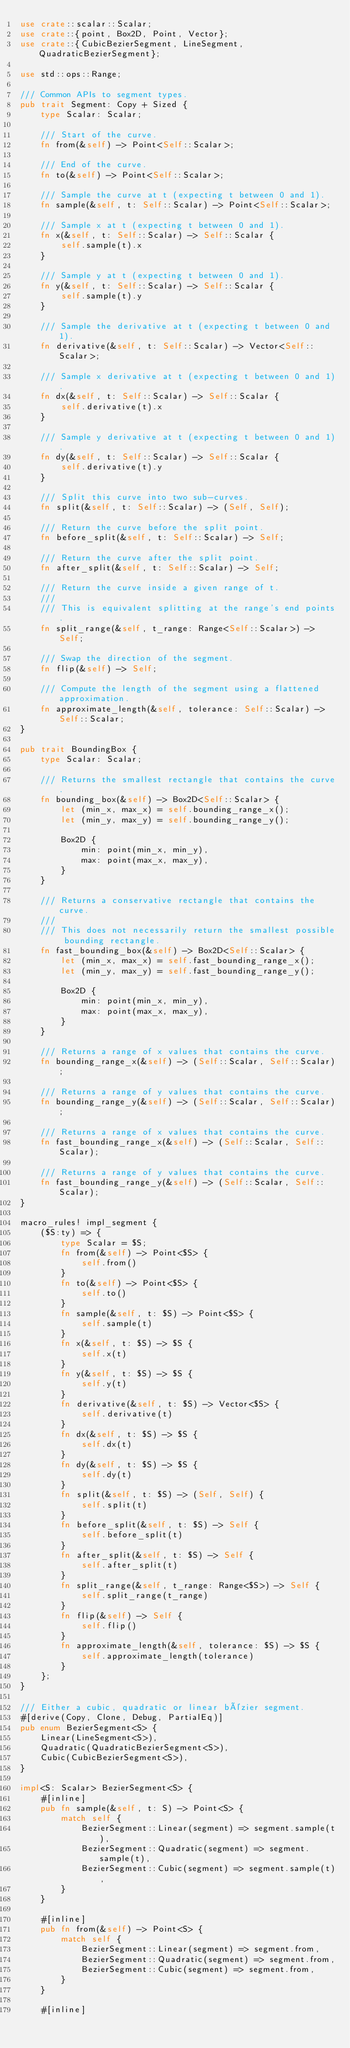Convert code to text. <code><loc_0><loc_0><loc_500><loc_500><_Rust_>use crate::scalar::Scalar;
use crate::{point, Box2D, Point, Vector};
use crate::{CubicBezierSegment, LineSegment, QuadraticBezierSegment};

use std::ops::Range;

/// Common APIs to segment types.
pub trait Segment: Copy + Sized {
    type Scalar: Scalar;

    /// Start of the curve.
    fn from(&self) -> Point<Self::Scalar>;

    /// End of the curve.
    fn to(&self) -> Point<Self::Scalar>;

    /// Sample the curve at t (expecting t between 0 and 1).
    fn sample(&self, t: Self::Scalar) -> Point<Self::Scalar>;

    /// Sample x at t (expecting t between 0 and 1).
    fn x(&self, t: Self::Scalar) -> Self::Scalar {
        self.sample(t).x
    }

    /// Sample y at t (expecting t between 0 and 1).
    fn y(&self, t: Self::Scalar) -> Self::Scalar {
        self.sample(t).y
    }

    /// Sample the derivative at t (expecting t between 0 and 1).
    fn derivative(&self, t: Self::Scalar) -> Vector<Self::Scalar>;

    /// Sample x derivative at t (expecting t between 0 and 1).
    fn dx(&self, t: Self::Scalar) -> Self::Scalar {
        self.derivative(t).x
    }

    /// Sample y derivative at t (expecting t between 0 and 1).
    fn dy(&self, t: Self::Scalar) -> Self::Scalar {
        self.derivative(t).y
    }

    /// Split this curve into two sub-curves.
    fn split(&self, t: Self::Scalar) -> (Self, Self);

    /// Return the curve before the split point.
    fn before_split(&self, t: Self::Scalar) -> Self;

    /// Return the curve after the split point.
    fn after_split(&self, t: Self::Scalar) -> Self;

    /// Return the curve inside a given range of t.
    ///
    /// This is equivalent splitting at the range's end points.
    fn split_range(&self, t_range: Range<Self::Scalar>) -> Self;

    /// Swap the direction of the segment.
    fn flip(&self) -> Self;

    /// Compute the length of the segment using a flattened approximation.
    fn approximate_length(&self, tolerance: Self::Scalar) -> Self::Scalar;
}

pub trait BoundingBox {
    type Scalar: Scalar;

    /// Returns the smallest rectangle that contains the curve.
    fn bounding_box(&self) -> Box2D<Self::Scalar> {
        let (min_x, max_x) = self.bounding_range_x();
        let (min_y, max_y) = self.bounding_range_y();

        Box2D {
            min: point(min_x, min_y),
            max: point(max_x, max_y),
        }
    }

    /// Returns a conservative rectangle that contains the curve.
    ///
    /// This does not necessarily return the smallest possible bounding rectangle.
    fn fast_bounding_box(&self) -> Box2D<Self::Scalar> {
        let (min_x, max_x) = self.fast_bounding_range_x();
        let (min_y, max_y) = self.fast_bounding_range_y();

        Box2D {
            min: point(min_x, min_y),
            max: point(max_x, max_y),
        }
    }

    /// Returns a range of x values that contains the curve.
    fn bounding_range_x(&self) -> (Self::Scalar, Self::Scalar);

    /// Returns a range of y values that contains the curve.
    fn bounding_range_y(&self) -> (Self::Scalar, Self::Scalar);

    /// Returns a range of x values that contains the curve.
    fn fast_bounding_range_x(&self) -> (Self::Scalar, Self::Scalar);

    /// Returns a range of y values that contains the curve.
    fn fast_bounding_range_y(&self) -> (Self::Scalar, Self::Scalar);
}

macro_rules! impl_segment {
    ($S:ty) => {
        type Scalar = $S;
        fn from(&self) -> Point<$S> {
            self.from()
        }
        fn to(&self) -> Point<$S> {
            self.to()
        }
        fn sample(&self, t: $S) -> Point<$S> {
            self.sample(t)
        }
        fn x(&self, t: $S) -> $S {
            self.x(t)
        }
        fn y(&self, t: $S) -> $S {
            self.y(t)
        }
        fn derivative(&self, t: $S) -> Vector<$S> {
            self.derivative(t)
        }
        fn dx(&self, t: $S) -> $S {
            self.dx(t)
        }
        fn dy(&self, t: $S) -> $S {
            self.dy(t)
        }
        fn split(&self, t: $S) -> (Self, Self) {
            self.split(t)
        }
        fn before_split(&self, t: $S) -> Self {
            self.before_split(t)
        }
        fn after_split(&self, t: $S) -> Self {
            self.after_split(t)
        }
        fn split_range(&self, t_range: Range<$S>) -> Self {
            self.split_range(t_range)
        }
        fn flip(&self) -> Self {
            self.flip()
        }
        fn approximate_length(&self, tolerance: $S) -> $S {
            self.approximate_length(tolerance)
        }
    };
}

/// Either a cubic, quadratic or linear bézier segment.
#[derive(Copy, Clone, Debug, PartialEq)]
pub enum BezierSegment<S> {
    Linear(LineSegment<S>),
    Quadratic(QuadraticBezierSegment<S>),
    Cubic(CubicBezierSegment<S>),
}

impl<S: Scalar> BezierSegment<S> {
    #[inline]
    pub fn sample(&self, t: S) -> Point<S> {
        match self {
            BezierSegment::Linear(segment) => segment.sample(t),
            BezierSegment::Quadratic(segment) => segment.sample(t),
            BezierSegment::Cubic(segment) => segment.sample(t),
        }
    }

    #[inline]
    pub fn from(&self) -> Point<S> {
        match self {
            BezierSegment::Linear(segment) => segment.from,
            BezierSegment::Quadratic(segment) => segment.from,
            BezierSegment::Cubic(segment) => segment.from,
        }
    }

    #[inline]</code> 